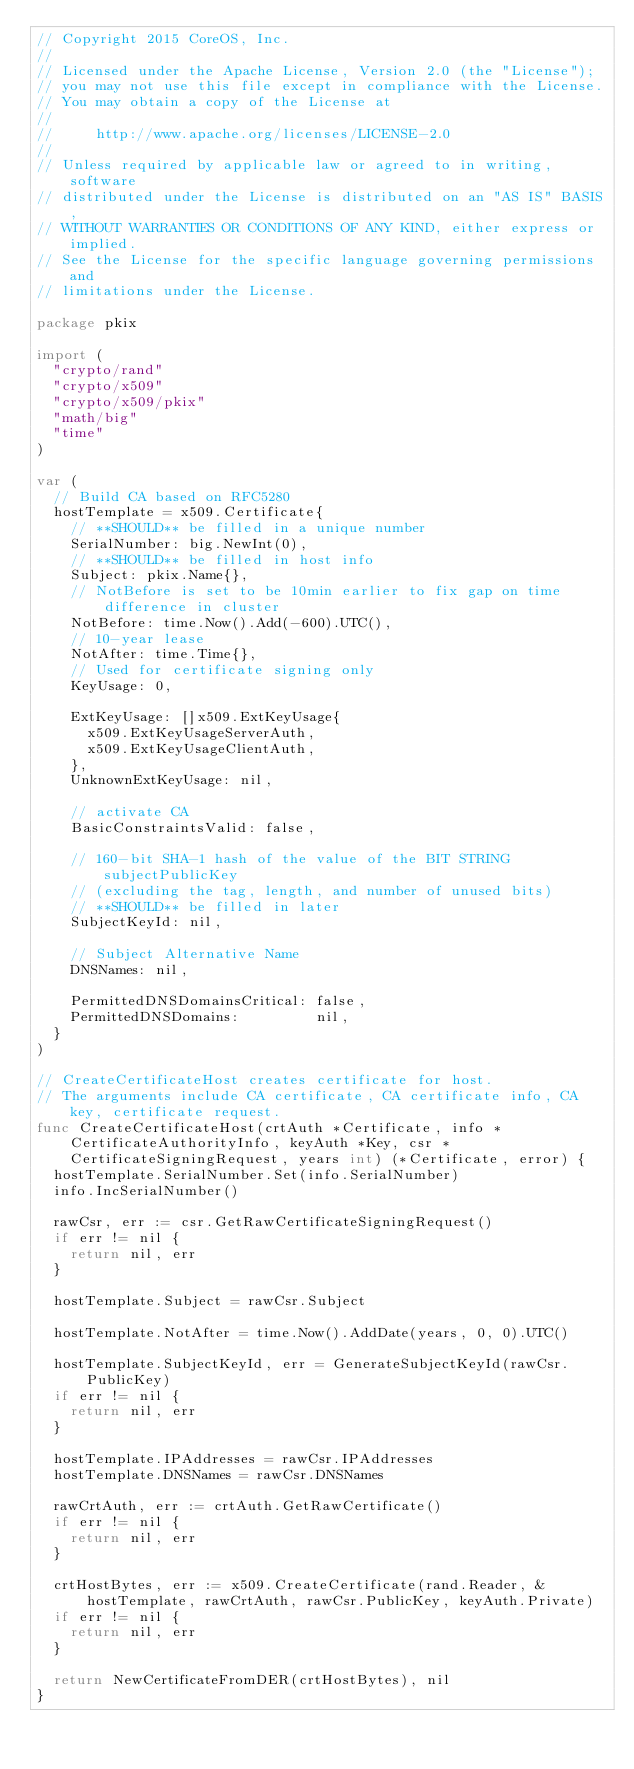<code> <loc_0><loc_0><loc_500><loc_500><_Go_>// Copyright 2015 CoreOS, Inc.
//
// Licensed under the Apache License, Version 2.0 (the "License");
// you may not use this file except in compliance with the License.
// You may obtain a copy of the License at
//
//     http://www.apache.org/licenses/LICENSE-2.0
//
// Unless required by applicable law or agreed to in writing, software
// distributed under the License is distributed on an "AS IS" BASIS,
// WITHOUT WARRANTIES OR CONDITIONS OF ANY KIND, either express or implied.
// See the License for the specific language governing permissions and
// limitations under the License.

package pkix

import (
	"crypto/rand"
	"crypto/x509"
	"crypto/x509/pkix"
	"math/big"
	"time"
)

var (
	// Build CA based on RFC5280
	hostTemplate = x509.Certificate{
		// **SHOULD** be filled in a unique number
		SerialNumber: big.NewInt(0),
		// **SHOULD** be filled in host info
		Subject: pkix.Name{},
		// NotBefore is set to be 10min earlier to fix gap on time difference in cluster
		NotBefore: time.Now().Add(-600).UTC(),
		// 10-year lease
		NotAfter: time.Time{},
		// Used for certificate signing only
		KeyUsage: 0,

		ExtKeyUsage: []x509.ExtKeyUsage{
			x509.ExtKeyUsageServerAuth,
			x509.ExtKeyUsageClientAuth,
		},
		UnknownExtKeyUsage: nil,

		// activate CA
		BasicConstraintsValid: false,

		// 160-bit SHA-1 hash of the value of the BIT STRING subjectPublicKey
		// (excluding the tag, length, and number of unused bits)
		// **SHOULD** be filled in later
		SubjectKeyId: nil,

		// Subject Alternative Name
		DNSNames: nil,

		PermittedDNSDomainsCritical: false,
		PermittedDNSDomains:         nil,
	}
)

// CreateCertificateHost creates certificate for host.
// The arguments include CA certificate, CA certificate info, CA key, certificate request.
func CreateCertificateHost(crtAuth *Certificate, info *CertificateAuthorityInfo, keyAuth *Key, csr *CertificateSigningRequest, years int) (*Certificate, error) {
	hostTemplate.SerialNumber.Set(info.SerialNumber)
	info.IncSerialNumber()

	rawCsr, err := csr.GetRawCertificateSigningRequest()
	if err != nil {
		return nil, err
	}

	hostTemplate.Subject = rawCsr.Subject

	hostTemplate.NotAfter = time.Now().AddDate(years, 0, 0).UTC()

	hostTemplate.SubjectKeyId, err = GenerateSubjectKeyId(rawCsr.PublicKey)
	if err != nil {
		return nil, err
	}

	hostTemplate.IPAddresses = rawCsr.IPAddresses
	hostTemplate.DNSNames = rawCsr.DNSNames

	rawCrtAuth, err := crtAuth.GetRawCertificate()
	if err != nil {
		return nil, err
	}

	crtHostBytes, err := x509.CreateCertificate(rand.Reader, &hostTemplate, rawCrtAuth, rawCsr.PublicKey, keyAuth.Private)
	if err != nil {
		return nil, err
	}

	return NewCertificateFromDER(crtHostBytes), nil
}
</code> 